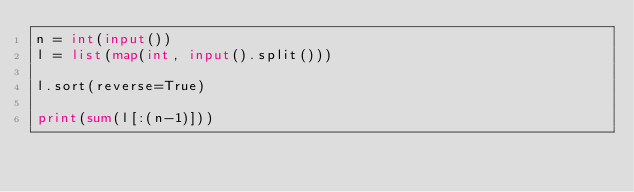<code> <loc_0><loc_0><loc_500><loc_500><_Python_>n = int(input())
l = list(map(int, input().split()))

l.sort(reverse=True)

print(sum(l[:(n-1)]))</code> 